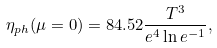<formula> <loc_0><loc_0><loc_500><loc_500>\eta _ { p h } ( \mu = 0 ) = 8 4 . 5 2 \frac { T ^ { 3 } } { e ^ { 4 } \ln e ^ { - 1 } } ,</formula> 